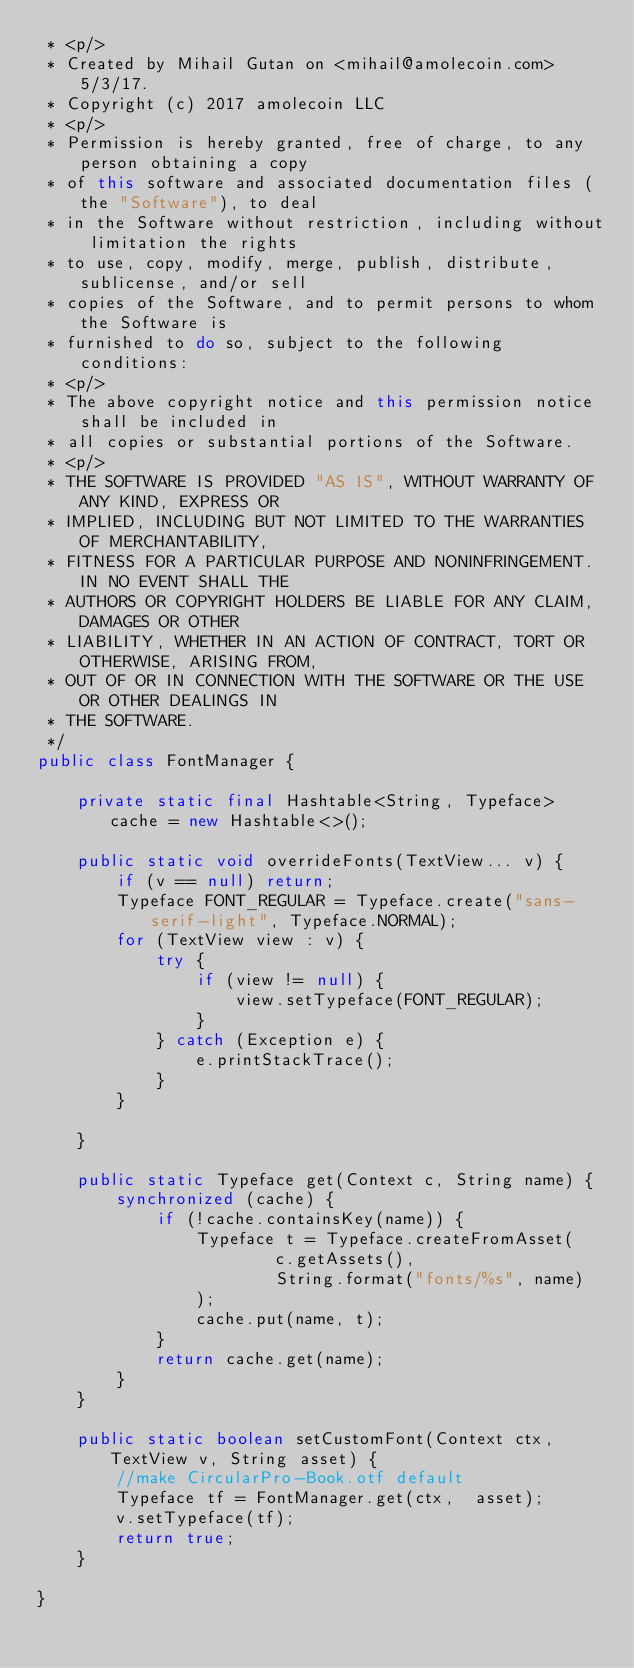<code> <loc_0><loc_0><loc_500><loc_500><_Java_> * <p/>
 * Created by Mihail Gutan on <mihail@amolecoin.com> 5/3/17.
 * Copyright (c) 2017 amolecoin LLC
 * <p/>
 * Permission is hereby granted, free of charge, to any person obtaining a copy
 * of this software and associated documentation files (the "Software"), to deal
 * in the Software without restriction, including without limitation the rights
 * to use, copy, modify, merge, publish, distribute, sublicense, and/or sell
 * copies of the Software, and to permit persons to whom the Software is
 * furnished to do so, subject to the following conditions:
 * <p/>
 * The above copyright notice and this permission notice shall be included in
 * all copies or substantial portions of the Software.
 * <p/>
 * THE SOFTWARE IS PROVIDED "AS IS", WITHOUT WARRANTY OF ANY KIND, EXPRESS OR
 * IMPLIED, INCLUDING BUT NOT LIMITED TO THE WARRANTIES OF MERCHANTABILITY,
 * FITNESS FOR A PARTICULAR PURPOSE AND NONINFRINGEMENT. IN NO EVENT SHALL THE
 * AUTHORS OR COPYRIGHT HOLDERS BE LIABLE FOR ANY CLAIM, DAMAGES OR OTHER
 * LIABILITY, WHETHER IN AN ACTION OF CONTRACT, TORT OR OTHERWISE, ARISING FROM,
 * OUT OF OR IN CONNECTION WITH THE SOFTWARE OR THE USE OR OTHER DEALINGS IN
 * THE SOFTWARE.
 */
public class FontManager {

    private static final Hashtable<String, Typeface> cache = new Hashtable<>();

    public static void overrideFonts(TextView... v) {
        if (v == null) return;
        Typeface FONT_REGULAR = Typeface.create("sans-serif-light", Typeface.NORMAL);
        for (TextView view : v) {
            try {
                if (view != null) {
                    view.setTypeface(FONT_REGULAR);
                }
            } catch (Exception e) {
                e.printStackTrace();
            }
        }

    }

    public static Typeface get(Context c, String name) {
        synchronized (cache) {
            if (!cache.containsKey(name)) {
                Typeface t = Typeface.createFromAsset(
                        c.getAssets(),
                        String.format("fonts/%s", name)
                );
                cache.put(name, t);
            }
            return cache.get(name);
        }
    }

    public static boolean setCustomFont(Context ctx, TextView v, String asset) {
        //make CircularPro-Book.otf default
        Typeface tf = FontManager.get(ctx,  asset);
        v.setTypeface(tf);
        return true;
    }

}
</code> 